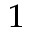Convert formula to latex. <formula><loc_0><loc_0><loc_500><loc_500>^ { 1 }</formula> 